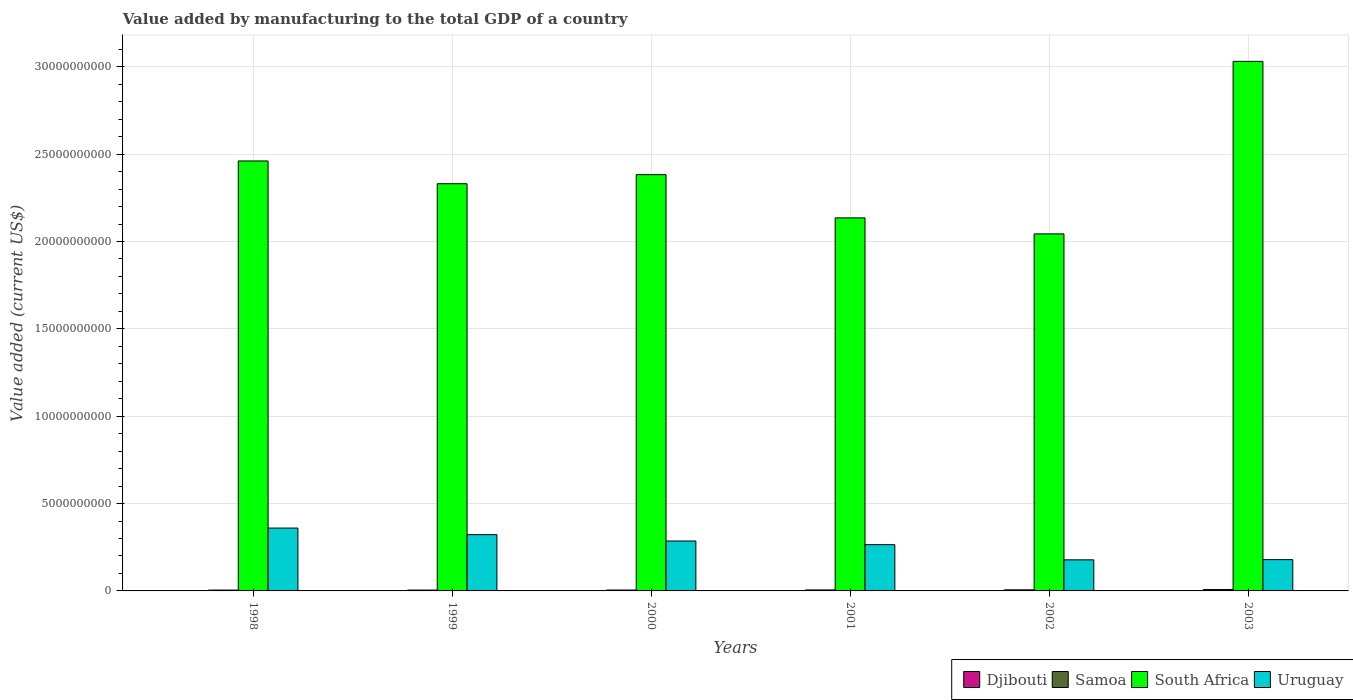How many groups of bars are there?
Provide a succinct answer. 6. Are the number of bars per tick equal to the number of legend labels?
Make the answer very short. Yes. Are the number of bars on each tick of the X-axis equal?
Offer a terse response. Yes. How many bars are there on the 2nd tick from the left?
Your answer should be compact. 4. How many bars are there on the 5th tick from the right?
Your answer should be very brief. 4. What is the value added by manufacturing to the total GDP in Samoa in 2003?
Offer a very short reply. 7.98e+07. Across all years, what is the maximum value added by manufacturing to the total GDP in South Africa?
Offer a very short reply. 3.03e+1. Across all years, what is the minimum value added by manufacturing to the total GDP in Djibouti?
Give a very brief answer. 1.21e+07. In which year was the value added by manufacturing to the total GDP in Samoa minimum?
Offer a very short reply. 1998. What is the total value added by manufacturing to the total GDP in Uruguay in the graph?
Provide a short and direct response. 1.59e+1. What is the difference between the value added by manufacturing to the total GDP in South Africa in 1998 and that in 2002?
Your answer should be very brief. 4.17e+09. What is the difference between the value added by manufacturing to the total GDP in South Africa in 1998 and the value added by manufacturing to the total GDP in Uruguay in 1999?
Offer a terse response. 2.14e+1. What is the average value added by manufacturing to the total GDP in South Africa per year?
Provide a short and direct response. 2.40e+1. In the year 2000, what is the difference between the value added by manufacturing to the total GDP in Samoa and value added by manufacturing to the total GDP in Djibouti?
Your answer should be very brief. 3.88e+07. What is the ratio of the value added by manufacturing to the total GDP in Uruguay in 1999 to that in 2000?
Ensure brevity in your answer.  1.13. Is the difference between the value added by manufacturing to the total GDP in Samoa in 2000 and 2002 greater than the difference between the value added by manufacturing to the total GDP in Djibouti in 2000 and 2002?
Make the answer very short. No. What is the difference between the highest and the second highest value added by manufacturing to the total GDP in Djibouti?
Give a very brief answer. 7.02e+05. What is the difference between the highest and the lowest value added by manufacturing to the total GDP in Samoa?
Your answer should be very brief. 3.14e+07. In how many years, is the value added by manufacturing to the total GDP in South Africa greater than the average value added by manufacturing to the total GDP in South Africa taken over all years?
Your answer should be very brief. 2. Is the sum of the value added by manufacturing to the total GDP in Samoa in 2001 and 2002 greater than the maximum value added by manufacturing to the total GDP in South Africa across all years?
Offer a terse response. No. What does the 1st bar from the left in 2001 represents?
Provide a succinct answer. Djibouti. What does the 2nd bar from the right in 1998 represents?
Keep it short and to the point. South Africa. How many bars are there?
Ensure brevity in your answer.  24. Does the graph contain grids?
Keep it short and to the point. Yes. Where does the legend appear in the graph?
Provide a short and direct response. Bottom right. What is the title of the graph?
Offer a terse response. Value added by manufacturing to the total GDP of a country. What is the label or title of the X-axis?
Keep it short and to the point. Years. What is the label or title of the Y-axis?
Provide a short and direct response. Value added (current US$). What is the Value added (current US$) in Djibouti in 1998?
Keep it short and to the point. 1.23e+07. What is the Value added (current US$) in Samoa in 1998?
Your answer should be very brief. 4.84e+07. What is the Value added (current US$) of South Africa in 1998?
Your answer should be compact. 2.46e+1. What is the Value added (current US$) of Uruguay in 1998?
Your answer should be compact. 3.60e+09. What is the Value added (current US$) in Djibouti in 1999?
Provide a short and direct response. 1.21e+07. What is the Value added (current US$) in Samoa in 1999?
Provide a succinct answer. 4.91e+07. What is the Value added (current US$) of South Africa in 1999?
Provide a short and direct response. 2.33e+1. What is the Value added (current US$) in Uruguay in 1999?
Offer a very short reply. 3.22e+09. What is the Value added (current US$) of Djibouti in 2000?
Make the answer very short. 1.26e+07. What is the Value added (current US$) in Samoa in 2000?
Make the answer very short. 5.13e+07. What is the Value added (current US$) in South Africa in 2000?
Provide a succinct answer. 2.38e+1. What is the Value added (current US$) of Uruguay in 2000?
Ensure brevity in your answer.  2.86e+09. What is the Value added (current US$) of Djibouti in 2001?
Your answer should be compact. 1.32e+07. What is the Value added (current US$) of Samoa in 2001?
Your response must be concise. 5.65e+07. What is the Value added (current US$) of South Africa in 2001?
Your response must be concise. 2.14e+1. What is the Value added (current US$) in Uruguay in 2001?
Ensure brevity in your answer.  2.65e+09. What is the Value added (current US$) of Djibouti in 2002?
Make the answer very short. 1.37e+07. What is the Value added (current US$) of Samoa in 2002?
Your answer should be very brief. 6.21e+07. What is the Value added (current US$) in South Africa in 2002?
Your response must be concise. 2.04e+1. What is the Value added (current US$) in Uruguay in 2002?
Offer a very short reply. 1.78e+09. What is the Value added (current US$) of Djibouti in 2003?
Your answer should be very brief. 1.44e+07. What is the Value added (current US$) of Samoa in 2003?
Provide a short and direct response. 7.98e+07. What is the Value added (current US$) in South Africa in 2003?
Give a very brief answer. 3.03e+1. What is the Value added (current US$) in Uruguay in 2003?
Keep it short and to the point. 1.79e+09. Across all years, what is the maximum Value added (current US$) in Djibouti?
Your response must be concise. 1.44e+07. Across all years, what is the maximum Value added (current US$) in Samoa?
Your response must be concise. 7.98e+07. Across all years, what is the maximum Value added (current US$) in South Africa?
Keep it short and to the point. 3.03e+1. Across all years, what is the maximum Value added (current US$) of Uruguay?
Your response must be concise. 3.60e+09. Across all years, what is the minimum Value added (current US$) in Djibouti?
Give a very brief answer. 1.21e+07. Across all years, what is the minimum Value added (current US$) in Samoa?
Offer a very short reply. 4.84e+07. Across all years, what is the minimum Value added (current US$) of South Africa?
Provide a short and direct response. 2.04e+1. Across all years, what is the minimum Value added (current US$) in Uruguay?
Provide a succinct answer. 1.78e+09. What is the total Value added (current US$) of Djibouti in the graph?
Your answer should be compact. 7.82e+07. What is the total Value added (current US$) in Samoa in the graph?
Provide a succinct answer. 3.47e+08. What is the total Value added (current US$) of South Africa in the graph?
Your answer should be compact. 1.44e+11. What is the total Value added (current US$) of Uruguay in the graph?
Keep it short and to the point. 1.59e+1. What is the difference between the Value added (current US$) of Djibouti in 1998 and that in 1999?
Keep it short and to the point. 2.48e+05. What is the difference between the Value added (current US$) of Samoa in 1998 and that in 1999?
Give a very brief answer. -6.89e+05. What is the difference between the Value added (current US$) in South Africa in 1998 and that in 1999?
Your answer should be very brief. 1.30e+09. What is the difference between the Value added (current US$) of Uruguay in 1998 and that in 1999?
Make the answer very short. 3.78e+08. What is the difference between the Value added (current US$) in Djibouti in 1998 and that in 2000?
Keep it short and to the point. -2.36e+05. What is the difference between the Value added (current US$) of Samoa in 1998 and that in 2000?
Provide a succinct answer. -2.97e+06. What is the difference between the Value added (current US$) of South Africa in 1998 and that in 2000?
Offer a terse response. 7.84e+08. What is the difference between the Value added (current US$) in Uruguay in 1998 and that in 2000?
Give a very brief answer. 7.40e+08. What is the difference between the Value added (current US$) in Djibouti in 1998 and that in 2001?
Your response must be concise. -8.54e+05. What is the difference between the Value added (current US$) of Samoa in 1998 and that in 2001?
Give a very brief answer. -8.10e+06. What is the difference between the Value added (current US$) in South Africa in 1998 and that in 2001?
Make the answer very short. 3.26e+09. What is the difference between the Value added (current US$) of Uruguay in 1998 and that in 2001?
Provide a succinct answer. 9.49e+08. What is the difference between the Value added (current US$) in Djibouti in 1998 and that in 2002?
Your answer should be very brief. -1.35e+06. What is the difference between the Value added (current US$) of Samoa in 1998 and that in 2002?
Offer a very short reply. -1.37e+07. What is the difference between the Value added (current US$) in South Africa in 1998 and that in 2002?
Provide a short and direct response. 4.17e+09. What is the difference between the Value added (current US$) in Uruguay in 1998 and that in 2002?
Keep it short and to the point. 1.82e+09. What is the difference between the Value added (current US$) of Djibouti in 1998 and that in 2003?
Give a very brief answer. -2.05e+06. What is the difference between the Value added (current US$) of Samoa in 1998 and that in 2003?
Offer a terse response. -3.14e+07. What is the difference between the Value added (current US$) in South Africa in 1998 and that in 2003?
Your answer should be very brief. -5.70e+09. What is the difference between the Value added (current US$) of Uruguay in 1998 and that in 2003?
Make the answer very short. 1.81e+09. What is the difference between the Value added (current US$) of Djibouti in 1999 and that in 2000?
Make the answer very short. -4.83e+05. What is the difference between the Value added (current US$) of Samoa in 1999 and that in 2000?
Your answer should be compact. -2.28e+06. What is the difference between the Value added (current US$) of South Africa in 1999 and that in 2000?
Your answer should be compact. -5.19e+08. What is the difference between the Value added (current US$) of Uruguay in 1999 and that in 2000?
Provide a succinct answer. 3.63e+08. What is the difference between the Value added (current US$) in Djibouti in 1999 and that in 2001?
Give a very brief answer. -1.10e+06. What is the difference between the Value added (current US$) in Samoa in 1999 and that in 2001?
Give a very brief answer. -7.41e+06. What is the difference between the Value added (current US$) of South Africa in 1999 and that in 2001?
Make the answer very short. 1.95e+09. What is the difference between the Value added (current US$) of Uruguay in 1999 and that in 2001?
Offer a very short reply. 5.71e+08. What is the difference between the Value added (current US$) of Djibouti in 1999 and that in 2002?
Your answer should be very brief. -1.60e+06. What is the difference between the Value added (current US$) of Samoa in 1999 and that in 2002?
Ensure brevity in your answer.  -1.30e+07. What is the difference between the Value added (current US$) of South Africa in 1999 and that in 2002?
Ensure brevity in your answer.  2.87e+09. What is the difference between the Value added (current US$) of Uruguay in 1999 and that in 2002?
Keep it short and to the point. 1.44e+09. What is the difference between the Value added (current US$) in Djibouti in 1999 and that in 2003?
Your response must be concise. -2.30e+06. What is the difference between the Value added (current US$) in Samoa in 1999 and that in 2003?
Provide a succinct answer. -3.07e+07. What is the difference between the Value added (current US$) in South Africa in 1999 and that in 2003?
Give a very brief answer. -7.01e+09. What is the difference between the Value added (current US$) of Uruguay in 1999 and that in 2003?
Offer a terse response. 1.43e+09. What is the difference between the Value added (current US$) in Djibouti in 2000 and that in 2001?
Give a very brief answer. -6.18e+05. What is the difference between the Value added (current US$) of Samoa in 2000 and that in 2001?
Offer a very short reply. -5.14e+06. What is the difference between the Value added (current US$) of South Africa in 2000 and that in 2001?
Offer a very short reply. 2.47e+09. What is the difference between the Value added (current US$) of Uruguay in 2000 and that in 2001?
Make the answer very short. 2.08e+08. What is the difference between the Value added (current US$) in Djibouti in 2000 and that in 2002?
Keep it short and to the point. -1.11e+06. What is the difference between the Value added (current US$) of Samoa in 2000 and that in 2002?
Make the answer very short. -1.08e+07. What is the difference between the Value added (current US$) of South Africa in 2000 and that in 2002?
Provide a succinct answer. 3.39e+09. What is the difference between the Value added (current US$) of Uruguay in 2000 and that in 2002?
Provide a succinct answer. 1.08e+09. What is the difference between the Value added (current US$) in Djibouti in 2000 and that in 2003?
Provide a succinct answer. -1.81e+06. What is the difference between the Value added (current US$) in Samoa in 2000 and that in 2003?
Ensure brevity in your answer.  -2.84e+07. What is the difference between the Value added (current US$) in South Africa in 2000 and that in 2003?
Provide a succinct answer. -6.49e+09. What is the difference between the Value added (current US$) in Uruguay in 2000 and that in 2003?
Provide a succinct answer. 1.07e+09. What is the difference between the Value added (current US$) in Djibouti in 2001 and that in 2002?
Keep it short and to the point. -4.95e+05. What is the difference between the Value added (current US$) in Samoa in 2001 and that in 2002?
Your answer should be very brief. -5.63e+06. What is the difference between the Value added (current US$) in South Africa in 2001 and that in 2002?
Your answer should be compact. 9.16e+08. What is the difference between the Value added (current US$) of Uruguay in 2001 and that in 2002?
Provide a short and direct response. 8.69e+08. What is the difference between the Value added (current US$) of Djibouti in 2001 and that in 2003?
Your answer should be very brief. -1.20e+06. What is the difference between the Value added (current US$) of Samoa in 2001 and that in 2003?
Keep it short and to the point. -2.33e+07. What is the difference between the Value added (current US$) in South Africa in 2001 and that in 2003?
Your response must be concise. -8.96e+09. What is the difference between the Value added (current US$) of Uruguay in 2001 and that in 2003?
Your response must be concise. 8.57e+08. What is the difference between the Value added (current US$) of Djibouti in 2002 and that in 2003?
Give a very brief answer. -7.02e+05. What is the difference between the Value added (current US$) of Samoa in 2002 and that in 2003?
Your answer should be very brief. -1.76e+07. What is the difference between the Value added (current US$) in South Africa in 2002 and that in 2003?
Provide a succinct answer. -9.88e+09. What is the difference between the Value added (current US$) in Uruguay in 2002 and that in 2003?
Give a very brief answer. -1.15e+07. What is the difference between the Value added (current US$) of Djibouti in 1998 and the Value added (current US$) of Samoa in 1999?
Offer a terse response. -3.67e+07. What is the difference between the Value added (current US$) of Djibouti in 1998 and the Value added (current US$) of South Africa in 1999?
Provide a succinct answer. -2.33e+1. What is the difference between the Value added (current US$) of Djibouti in 1998 and the Value added (current US$) of Uruguay in 1999?
Your answer should be compact. -3.21e+09. What is the difference between the Value added (current US$) of Samoa in 1998 and the Value added (current US$) of South Africa in 1999?
Your answer should be compact. -2.33e+1. What is the difference between the Value added (current US$) of Samoa in 1998 and the Value added (current US$) of Uruguay in 1999?
Ensure brevity in your answer.  -3.17e+09. What is the difference between the Value added (current US$) of South Africa in 1998 and the Value added (current US$) of Uruguay in 1999?
Your answer should be very brief. 2.14e+1. What is the difference between the Value added (current US$) of Djibouti in 1998 and the Value added (current US$) of Samoa in 2000?
Your answer should be compact. -3.90e+07. What is the difference between the Value added (current US$) in Djibouti in 1998 and the Value added (current US$) in South Africa in 2000?
Your response must be concise. -2.38e+1. What is the difference between the Value added (current US$) of Djibouti in 1998 and the Value added (current US$) of Uruguay in 2000?
Provide a succinct answer. -2.84e+09. What is the difference between the Value added (current US$) of Samoa in 1998 and the Value added (current US$) of South Africa in 2000?
Your response must be concise. -2.38e+1. What is the difference between the Value added (current US$) in Samoa in 1998 and the Value added (current US$) in Uruguay in 2000?
Your answer should be compact. -2.81e+09. What is the difference between the Value added (current US$) in South Africa in 1998 and the Value added (current US$) in Uruguay in 2000?
Make the answer very short. 2.18e+1. What is the difference between the Value added (current US$) of Djibouti in 1998 and the Value added (current US$) of Samoa in 2001?
Provide a short and direct response. -4.41e+07. What is the difference between the Value added (current US$) of Djibouti in 1998 and the Value added (current US$) of South Africa in 2001?
Ensure brevity in your answer.  -2.13e+1. What is the difference between the Value added (current US$) of Djibouti in 1998 and the Value added (current US$) of Uruguay in 2001?
Your answer should be compact. -2.64e+09. What is the difference between the Value added (current US$) of Samoa in 1998 and the Value added (current US$) of South Africa in 2001?
Provide a succinct answer. -2.13e+1. What is the difference between the Value added (current US$) in Samoa in 1998 and the Value added (current US$) in Uruguay in 2001?
Provide a succinct answer. -2.60e+09. What is the difference between the Value added (current US$) of South Africa in 1998 and the Value added (current US$) of Uruguay in 2001?
Keep it short and to the point. 2.20e+1. What is the difference between the Value added (current US$) in Djibouti in 1998 and the Value added (current US$) in Samoa in 2002?
Ensure brevity in your answer.  -4.98e+07. What is the difference between the Value added (current US$) of Djibouti in 1998 and the Value added (current US$) of South Africa in 2002?
Provide a short and direct response. -2.04e+1. What is the difference between the Value added (current US$) of Djibouti in 1998 and the Value added (current US$) of Uruguay in 2002?
Your answer should be very brief. -1.77e+09. What is the difference between the Value added (current US$) of Samoa in 1998 and the Value added (current US$) of South Africa in 2002?
Your response must be concise. -2.04e+1. What is the difference between the Value added (current US$) in Samoa in 1998 and the Value added (current US$) in Uruguay in 2002?
Ensure brevity in your answer.  -1.73e+09. What is the difference between the Value added (current US$) of South Africa in 1998 and the Value added (current US$) of Uruguay in 2002?
Offer a terse response. 2.28e+1. What is the difference between the Value added (current US$) of Djibouti in 1998 and the Value added (current US$) of Samoa in 2003?
Give a very brief answer. -6.74e+07. What is the difference between the Value added (current US$) of Djibouti in 1998 and the Value added (current US$) of South Africa in 2003?
Ensure brevity in your answer.  -3.03e+1. What is the difference between the Value added (current US$) of Djibouti in 1998 and the Value added (current US$) of Uruguay in 2003?
Your answer should be very brief. -1.78e+09. What is the difference between the Value added (current US$) in Samoa in 1998 and the Value added (current US$) in South Africa in 2003?
Make the answer very short. -3.03e+1. What is the difference between the Value added (current US$) in Samoa in 1998 and the Value added (current US$) in Uruguay in 2003?
Make the answer very short. -1.74e+09. What is the difference between the Value added (current US$) of South Africa in 1998 and the Value added (current US$) of Uruguay in 2003?
Offer a very short reply. 2.28e+1. What is the difference between the Value added (current US$) in Djibouti in 1999 and the Value added (current US$) in Samoa in 2000?
Keep it short and to the point. -3.93e+07. What is the difference between the Value added (current US$) in Djibouti in 1999 and the Value added (current US$) in South Africa in 2000?
Make the answer very short. -2.38e+1. What is the difference between the Value added (current US$) of Djibouti in 1999 and the Value added (current US$) of Uruguay in 2000?
Offer a terse response. -2.85e+09. What is the difference between the Value added (current US$) of Samoa in 1999 and the Value added (current US$) of South Africa in 2000?
Provide a succinct answer. -2.38e+1. What is the difference between the Value added (current US$) in Samoa in 1999 and the Value added (current US$) in Uruguay in 2000?
Offer a terse response. -2.81e+09. What is the difference between the Value added (current US$) in South Africa in 1999 and the Value added (current US$) in Uruguay in 2000?
Your answer should be very brief. 2.05e+1. What is the difference between the Value added (current US$) of Djibouti in 1999 and the Value added (current US$) of Samoa in 2001?
Your answer should be very brief. -4.44e+07. What is the difference between the Value added (current US$) in Djibouti in 1999 and the Value added (current US$) in South Africa in 2001?
Your response must be concise. -2.13e+1. What is the difference between the Value added (current US$) in Djibouti in 1999 and the Value added (current US$) in Uruguay in 2001?
Your answer should be compact. -2.64e+09. What is the difference between the Value added (current US$) in Samoa in 1999 and the Value added (current US$) in South Africa in 2001?
Keep it short and to the point. -2.13e+1. What is the difference between the Value added (current US$) in Samoa in 1999 and the Value added (current US$) in Uruguay in 2001?
Offer a very short reply. -2.60e+09. What is the difference between the Value added (current US$) in South Africa in 1999 and the Value added (current US$) in Uruguay in 2001?
Provide a short and direct response. 2.07e+1. What is the difference between the Value added (current US$) of Djibouti in 1999 and the Value added (current US$) of Samoa in 2002?
Offer a terse response. -5.00e+07. What is the difference between the Value added (current US$) in Djibouti in 1999 and the Value added (current US$) in South Africa in 2002?
Provide a succinct answer. -2.04e+1. What is the difference between the Value added (current US$) in Djibouti in 1999 and the Value added (current US$) in Uruguay in 2002?
Offer a very short reply. -1.77e+09. What is the difference between the Value added (current US$) in Samoa in 1999 and the Value added (current US$) in South Africa in 2002?
Your answer should be compact. -2.04e+1. What is the difference between the Value added (current US$) of Samoa in 1999 and the Value added (current US$) of Uruguay in 2002?
Provide a short and direct response. -1.73e+09. What is the difference between the Value added (current US$) in South Africa in 1999 and the Value added (current US$) in Uruguay in 2002?
Give a very brief answer. 2.15e+1. What is the difference between the Value added (current US$) of Djibouti in 1999 and the Value added (current US$) of Samoa in 2003?
Your response must be concise. -6.77e+07. What is the difference between the Value added (current US$) of Djibouti in 1999 and the Value added (current US$) of South Africa in 2003?
Offer a terse response. -3.03e+1. What is the difference between the Value added (current US$) of Djibouti in 1999 and the Value added (current US$) of Uruguay in 2003?
Make the answer very short. -1.78e+09. What is the difference between the Value added (current US$) of Samoa in 1999 and the Value added (current US$) of South Africa in 2003?
Offer a very short reply. -3.03e+1. What is the difference between the Value added (current US$) in Samoa in 1999 and the Value added (current US$) in Uruguay in 2003?
Keep it short and to the point. -1.74e+09. What is the difference between the Value added (current US$) in South Africa in 1999 and the Value added (current US$) in Uruguay in 2003?
Offer a terse response. 2.15e+1. What is the difference between the Value added (current US$) of Djibouti in 2000 and the Value added (current US$) of Samoa in 2001?
Your response must be concise. -4.39e+07. What is the difference between the Value added (current US$) in Djibouti in 2000 and the Value added (current US$) in South Africa in 2001?
Give a very brief answer. -2.13e+1. What is the difference between the Value added (current US$) in Djibouti in 2000 and the Value added (current US$) in Uruguay in 2001?
Give a very brief answer. -2.64e+09. What is the difference between the Value added (current US$) in Samoa in 2000 and the Value added (current US$) in South Africa in 2001?
Your answer should be compact. -2.13e+1. What is the difference between the Value added (current US$) in Samoa in 2000 and the Value added (current US$) in Uruguay in 2001?
Offer a terse response. -2.60e+09. What is the difference between the Value added (current US$) in South Africa in 2000 and the Value added (current US$) in Uruguay in 2001?
Your answer should be compact. 2.12e+1. What is the difference between the Value added (current US$) in Djibouti in 2000 and the Value added (current US$) in Samoa in 2002?
Keep it short and to the point. -4.95e+07. What is the difference between the Value added (current US$) of Djibouti in 2000 and the Value added (current US$) of South Africa in 2002?
Your answer should be very brief. -2.04e+1. What is the difference between the Value added (current US$) of Djibouti in 2000 and the Value added (current US$) of Uruguay in 2002?
Your answer should be compact. -1.77e+09. What is the difference between the Value added (current US$) in Samoa in 2000 and the Value added (current US$) in South Africa in 2002?
Your answer should be very brief. -2.04e+1. What is the difference between the Value added (current US$) in Samoa in 2000 and the Value added (current US$) in Uruguay in 2002?
Give a very brief answer. -1.73e+09. What is the difference between the Value added (current US$) in South Africa in 2000 and the Value added (current US$) in Uruguay in 2002?
Keep it short and to the point. 2.20e+1. What is the difference between the Value added (current US$) in Djibouti in 2000 and the Value added (current US$) in Samoa in 2003?
Offer a terse response. -6.72e+07. What is the difference between the Value added (current US$) in Djibouti in 2000 and the Value added (current US$) in South Africa in 2003?
Offer a very short reply. -3.03e+1. What is the difference between the Value added (current US$) in Djibouti in 2000 and the Value added (current US$) in Uruguay in 2003?
Offer a very short reply. -1.78e+09. What is the difference between the Value added (current US$) in Samoa in 2000 and the Value added (current US$) in South Africa in 2003?
Provide a short and direct response. -3.03e+1. What is the difference between the Value added (current US$) in Samoa in 2000 and the Value added (current US$) in Uruguay in 2003?
Your answer should be compact. -1.74e+09. What is the difference between the Value added (current US$) in South Africa in 2000 and the Value added (current US$) in Uruguay in 2003?
Make the answer very short. 2.20e+1. What is the difference between the Value added (current US$) of Djibouti in 2001 and the Value added (current US$) of Samoa in 2002?
Make the answer very short. -4.89e+07. What is the difference between the Value added (current US$) in Djibouti in 2001 and the Value added (current US$) in South Africa in 2002?
Keep it short and to the point. -2.04e+1. What is the difference between the Value added (current US$) in Djibouti in 2001 and the Value added (current US$) in Uruguay in 2002?
Offer a terse response. -1.77e+09. What is the difference between the Value added (current US$) of Samoa in 2001 and the Value added (current US$) of South Africa in 2002?
Your answer should be very brief. -2.04e+1. What is the difference between the Value added (current US$) of Samoa in 2001 and the Value added (current US$) of Uruguay in 2002?
Offer a terse response. -1.72e+09. What is the difference between the Value added (current US$) in South Africa in 2001 and the Value added (current US$) in Uruguay in 2002?
Your response must be concise. 1.96e+1. What is the difference between the Value added (current US$) in Djibouti in 2001 and the Value added (current US$) in Samoa in 2003?
Your answer should be compact. -6.66e+07. What is the difference between the Value added (current US$) of Djibouti in 2001 and the Value added (current US$) of South Africa in 2003?
Your answer should be compact. -3.03e+1. What is the difference between the Value added (current US$) of Djibouti in 2001 and the Value added (current US$) of Uruguay in 2003?
Provide a succinct answer. -1.78e+09. What is the difference between the Value added (current US$) in Samoa in 2001 and the Value added (current US$) in South Africa in 2003?
Give a very brief answer. -3.03e+1. What is the difference between the Value added (current US$) of Samoa in 2001 and the Value added (current US$) of Uruguay in 2003?
Offer a terse response. -1.73e+09. What is the difference between the Value added (current US$) in South Africa in 2001 and the Value added (current US$) in Uruguay in 2003?
Provide a short and direct response. 1.96e+1. What is the difference between the Value added (current US$) in Djibouti in 2002 and the Value added (current US$) in Samoa in 2003?
Keep it short and to the point. -6.61e+07. What is the difference between the Value added (current US$) in Djibouti in 2002 and the Value added (current US$) in South Africa in 2003?
Your answer should be very brief. -3.03e+1. What is the difference between the Value added (current US$) in Djibouti in 2002 and the Value added (current US$) in Uruguay in 2003?
Provide a short and direct response. -1.78e+09. What is the difference between the Value added (current US$) in Samoa in 2002 and the Value added (current US$) in South Africa in 2003?
Your answer should be compact. -3.03e+1. What is the difference between the Value added (current US$) in Samoa in 2002 and the Value added (current US$) in Uruguay in 2003?
Your answer should be very brief. -1.73e+09. What is the difference between the Value added (current US$) in South Africa in 2002 and the Value added (current US$) in Uruguay in 2003?
Make the answer very short. 1.86e+1. What is the average Value added (current US$) of Djibouti per year?
Ensure brevity in your answer.  1.30e+07. What is the average Value added (current US$) in Samoa per year?
Your answer should be compact. 5.79e+07. What is the average Value added (current US$) of South Africa per year?
Your answer should be very brief. 2.40e+1. What is the average Value added (current US$) in Uruguay per year?
Provide a succinct answer. 2.65e+09. In the year 1998, what is the difference between the Value added (current US$) of Djibouti and Value added (current US$) of Samoa?
Your answer should be very brief. -3.60e+07. In the year 1998, what is the difference between the Value added (current US$) of Djibouti and Value added (current US$) of South Africa?
Your response must be concise. -2.46e+1. In the year 1998, what is the difference between the Value added (current US$) of Djibouti and Value added (current US$) of Uruguay?
Offer a terse response. -3.59e+09. In the year 1998, what is the difference between the Value added (current US$) in Samoa and Value added (current US$) in South Africa?
Your response must be concise. -2.46e+1. In the year 1998, what is the difference between the Value added (current US$) in Samoa and Value added (current US$) in Uruguay?
Your answer should be compact. -3.55e+09. In the year 1998, what is the difference between the Value added (current US$) in South Africa and Value added (current US$) in Uruguay?
Ensure brevity in your answer.  2.10e+1. In the year 1999, what is the difference between the Value added (current US$) in Djibouti and Value added (current US$) in Samoa?
Your answer should be compact. -3.70e+07. In the year 1999, what is the difference between the Value added (current US$) in Djibouti and Value added (current US$) in South Africa?
Make the answer very short. -2.33e+1. In the year 1999, what is the difference between the Value added (current US$) of Djibouti and Value added (current US$) of Uruguay?
Provide a short and direct response. -3.21e+09. In the year 1999, what is the difference between the Value added (current US$) of Samoa and Value added (current US$) of South Africa?
Provide a short and direct response. -2.33e+1. In the year 1999, what is the difference between the Value added (current US$) of Samoa and Value added (current US$) of Uruguay?
Your response must be concise. -3.17e+09. In the year 1999, what is the difference between the Value added (current US$) of South Africa and Value added (current US$) of Uruguay?
Keep it short and to the point. 2.01e+1. In the year 2000, what is the difference between the Value added (current US$) in Djibouti and Value added (current US$) in Samoa?
Provide a succinct answer. -3.88e+07. In the year 2000, what is the difference between the Value added (current US$) in Djibouti and Value added (current US$) in South Africa?
Offer a very short reply. -2.38e+1. In the year 2000, what is the difference between the Value added (current US$) in Djibouti and Value added (current US$) in Uruguay?
Make the answer very short. -2.84e+09. In the year 2000, what is the difference between the Value added (current US$) of Samoa and Value added (current US$) of South Africa?
Your answer should be very brief. -2.38e+1. In the year 2000, what is the difference between the Value added (current US$) in Samoa and Value added (current US$) in Uruguay?
Make the answer very short. -2.81e+09. In the year 2000, what is the difference between the Value added (current US$) in South Africa and Value added (current US$) in Uruguay?
Offer a very short reply. 2.10e+1. In the year 2001, what is the difference between the Value added (current US$) in Djibouti and Value added (current US$) in Samoa?
Keep it short and to the point. -4.33e+07. In the year 2001, what is the difference between the Value added (current US$) of Djibouti and Value added (current US$) of South Africa?
Provide a succinct answer. -2.13e+1. In the year 2001, what is the difference between the Value added (current US$) in Djibouti and Value added (current US$) in Uruguay?
Keep it short and to the point. -2.64e+09. In the year 2001, what is the difference between the Value added (current US$) in Samoa and Value added (current US$) in South Africa?
Your answer should be very brief. -2.13e+1. In the year 2001, what is the difference between the Value added (current US$) in Samoa and Value added (current US$) in Uruguay?
Offer a very short reply. -2.59e+09. In the year 2001, what is the difference between the Value added (current US$) in South Africa and Value added (current US$) in Uruguay?
Provide a short and direct response. 1.87e+1. In the year 2002, what is the difference between the Value added (current US$) in Djibouti and Value added (current US$) in Samoa?
Give a very brief answer. -4.84e+07. In the year 2002, what is the difference between the Value added (current US$) in Djibouti and Value added (current US$) in South Africa?
Your answer should be compact. -2.04e+1. In the year 2002, what is the difference between the Value added (current US$) in Djibouti and Value added (current US$) in Uruguay?
Provide a succinct answer. -1.77e+09. In the year 2002, what is the difference between the Value added (current US$) of Samoa and Value added (current US$) of South Africa?
Your response must be concise. -2.04e+1. In the year 2002, what is the difference between the Value added (current US$) of Samoa and Value added (current US$) of Uruguay?
Keep it short and to the point. -1.72e+09. In the year 2002, what is the difference between the Value added (current US$) of South Africa and Value added (current US$) of Uruguay?
Offer a very short reply. 1.87e+1. In the year 2003, what is the difference between the Value added (current US$) in Djibouti and Value added (current US$) in Samoa?
Your answer should be very brief. -6.54e+07. In the year 2003, what is the difference between the Value added (current US$) in Djibouti and Value added (current US$) in South Africa?
Your response must be concise. -3.03e+1. In the year 2003, what is the difference between the Value added (current US$) in Djibouti and Value added (current US$) in Uruguay?
Keep it short and to the point. -1.78e+09. In the year 2003, what is the difference between the Value added (current US$) of Samoa and Value added (current US$) of South Africa?
Provide a succinct answer. -3.02e+1. In the year 2003, what is the difference between the Value added (current US$) in Samoa and Value added (current US$) in Uruguay?
Your response must be concise. -1.71e+09. In the year 2003, what is the difference between the Value added (current US$) of South Africa and Value added (current US$) of Uruguay?
Offer a terse response. 2.85e+1. What is the ratio of the Value added (current US$) of Djibouti in 1998 to that in 1999?
Provide a short and direct response. 1.02. What is the ratio of the Value added (current US$) of Samoa in 1998 to that in 1999?
Provide a succinct answer. 0.99. What is the ratio of the Value added (current US$) of South Africa in 1998 to that in 1999?
Ensure brevity in your answer.  1.06. What is the ratio of the Value added (current US$) of Uruguay in 1998 to that in 1999?
Give a very brief answer. 1.12. What is the ratio of the Value added (current US$) in Djibouti in 1998 to that in 2000?
Keep it short and to the point. 0.98. What is the ratio of the Value added (current US$) in Samoa in 1998 to that in 2000?
Offer a very short reply. 0.94. What is the ratio of the Value added (current US$) in South Africa in 1998 to that in 2000?
Ensure brevity in your answer.  1.03. What is the ratio of the Value added (current US$) in Uruguay in 1998 to that in 2000?
Your answer should be very brief. 1.26. What is the ratio of the Value added (current US$) of Djibouti in 1998 to that in 2001?
Provide a short and direct response. 0.94. What is the ratio of the Value added (current US$) of Samoa in 1998 to that in 2001?
Make the answer very short. 0.86. What is the ratio of the Value added (current US$) of South Africa in 1998 to that in 2001?
Ensure brevity in your answer.  1.15. What is the ratio of the Value added (current US$) of Uruguay in 1998 to that in 2001?
Offer a very short reply. 1.36. What is the ratio of the Value added (current US$) in Djibouti in 1998 to that in 2002?
Your answer should be compact. 0.9. What is the ratio of the Value added (current US$) in Samoa in 1998 to that in 2002?
Your response must be concise. 0.78. What is the ratio of the Value added (current US$) of South Africa in 1998 to that in 2002?
Keep it short and to the point. 1.2. What is the ratio of the Value added (current US$) of Uruguay in 1998 to that in 2002?
Keep it short and to the point. 2.02. What is the ratio of the Value added (current US$) in Djibouti in 1998 to that in 2003?
Your response must be concise. 0.86. What is the ratio of the Value added (current US$) of Samoa in 1998 to that in 2003?
Provide a succinct answer. 0.61. What is the ratio of the Value added (current US$) of South Africa in 1998 to that in 2003?
Keep it short and to the point. 0.81. What is the ratio of the Value added (current US$) of Uruguay in 1998 to that in 2003?
Offer a terse response. 2.01. What is the ratio of the Value added (current US$) of Djibouti in 1999 to that in 2000?
Your response must be concise. 0.96. What is the ratio of the Value added (current US$) of Samoa in 1999 to that in 2000?
Your answer should be compact. 0.96. What is the ratio of the Value added (current US$) in South Africa in 1999 to that in 2000?
Your response must be concise. 0.98. What is the ratio of the Value added (current US$) in Uruguay in 1999 to that in 2000?
Provide a succinct answer. 1.13. What is the ratio of the Value added (current US$) of Djibouti in 1999 to that in 2001?
Your answer should be compact. 0.92. What is the ratio of the Value added (current US$) in Samoa in 1999 to that in 2001?
Offer a very short reply. 0.87. What is the ratio of the Value added (current US$) of South Africa in 1999 to that in 2001?
Provide a short and direct response. 1.09. What is the ratio of the Value added (current US$) in Uruguay in 1999 to that in 2001?
Your answer should be very brief. 1.22. What is the ratio of the Value added (current US$) of Djibouti in 1999 to that in 2002?
Provide a short and direct response. 0.88. What is the ratio of the Value added (current US$) in Samoa in 1999 to that in 2002?
Your response must be concise. 0.79. What is the ratio of the Value added (current US$) of South Africa in 1999 to that in 2002?
Provide a succinct answer. 1.14. What is the ratio of the Value added (current US$) of Uruguay in 1999 to that in 2002?
Provide a succinct answer. 1.81. What is the ratio of the Value added (current US$) in Djibouti in 1999 to that in 2003?
Your answer should be very brief. 0.84. What is the ratio of the Value added (current US$) in Samoa in 1999 to that in 2003?
Your answer should be very brief. 0.62. What is the ratio of the Value added (current US$) of South Africa in 1999 to that in 2003?
Ensure brevity in your answer.  0.77. What is the ratio of the Value added (current US$) of Uruguay in 1999 to that in 2003?
Ensure brevity in your answer.  1.8. What is the ratio of the Value added (current US$) of Djibouti in 2000 to that in 2001?
Provide a short and direct response. 0.95. What is the ratio of the Value added (current US$) in South Africa in 2000 to that in 2001?
Keep it short and to the point. 1.12. What is the ratio of the Value added (current US$) in Uruguay in 2000 to that in 2001?
Offer a very short reply. 1.08. What is the ratio of the Value added (current US$) in Djibouti in 2000 to that in 2002?
Your answer should be compact. 0.92. What is the ratio of the Value added (current US$) in Samoa in 2000 to that in 2002?
Provide a succinct answer. 0.83. What is the ratio of the Value added (current US$) in South Africa in 2000 to that in 2002?
Offer a terse response. 1.17. What is the ratio of the Value added (current US$) of Uruguay in 2000 to that in 2002?
Make the answer very short. 1.61. What is the ratio of the Value added (current US$) in Djibouti in 2000 to that in 2003?
Offer a very short reply. 0.87. What is the ratio of the Value added (current US$) of Samoa in 2000 to that in 2003?
Provide a succinct answer. 0.64. What is the ratio of the Value added (current US$) in South Africa in 2000 to that in 2003?
Offer a terse response. 0.79. What is the ratio of the Value added (current US$) in Uruguay in 2000 to that in 2003?
Offer a terse response. 1.59. What is the ratio of the Value added (current US$) of Djibouti in 2001 to that in 2002?
Provide a short and direct response. 0.96. What is the ratio of the Value added (current US$) of Samoa in 2001 to that in 2002?
Your response must be concise. 0.91. What is the ratio of the Value added (current US$) of South Africa in 2001 to that in 2002?
Your response must be concise. 1.04. What is the ratio of the Value added (current US$) of Uruguay in 2001 to that in 2002?
Offer a very short reply. 1.49. What is the ratio of the Value added (current US$) in Djibouti in 2001 to that in 2003?
Give a very brief answer. 0.92. What is the ratio of the Value added (current US$) in Samoa in 2001 to that in 2003?
Provide a short and direct response. 0.71. What is the ratio of the Value added (current US$) in South Africa in 2001 to that in 2003?
Your response must be concise. 0.7. What is the ratio of the Value added (current US$) in Uruguay in 2001 to that in 2003?
Give a very brief answer. 1.48. What is the ratio of the Value added (current US$) of Djibouti in 2002 to that in 2003?
Make the answer very short. 0.95. What is the ratio of the Value added (current US$) of Samoa in 2002 to that in 2003?
Provide a short and direct response. 0.78. What is the ratio of the Value added (current US$) in South Africa in 2002 to that in 2003?
Give a very brief answer. 0.67. What is the difference between the highest and the second highest Value added (current US$) of Djibouti?
Offer a terse response. 7.02e+05. What is the difference between the highest and the second highest Value added (current US$) in Samoa?
Make the answer very short. 1.76e+07. What is the difference between the highest and the second highest Value added (current US$) of South Africa?
Give a very brief answer. 5.70e+09. What is the difference between the highest and the second highest Value added (current US$) in Uruguay?
Ensure brevity in your answer.  3.78e+08. What is the difference between the highest and the lowest Value added (current US$) in Djibouti?
Provide a succinct answer. 2.30e+06. What is the difference between the highest and the lowest Value added (current US$) of Samoa?
Your answer should be compact. 3.14e+07. What is the difference between the highest and the lowest Value added (current US$) in South Africa?
Your answer should be compact. 9.88e+09. What is the difference between the highest and the lowest Value added (current US$) of Uruguay?
Give a very brief answer. 1.82e+09. 